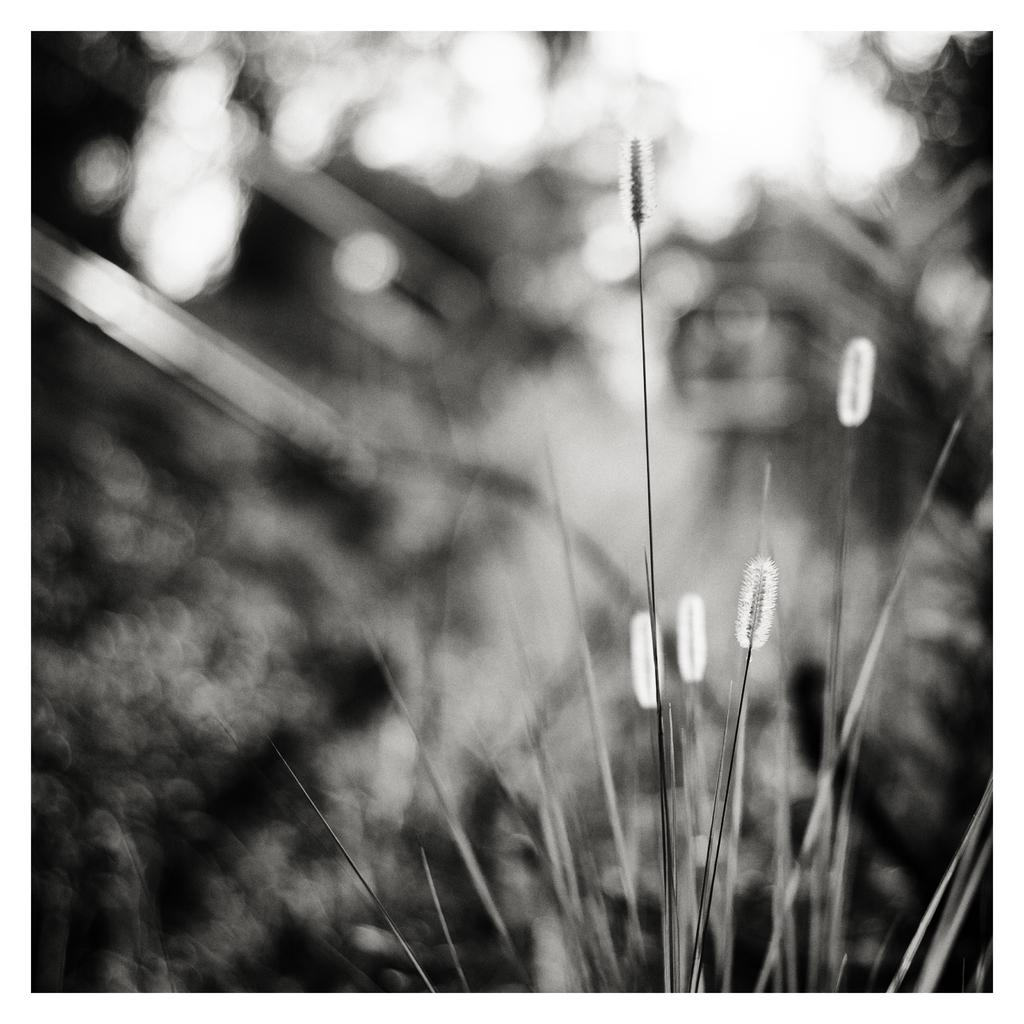What is the color scheme of the image? The image is black and white. What type of vegetation is present at the bottom of the image? There is grass at the bottom of the image. Can you describe the background of the image? The background of the image is blurry. What rule is being enforced in the image? There is no rule being enforced in the image, as it is a black and white image with grass at the bottom and a blurry background. What country is depicted in the image? The image does not depict a specific country; it is a black and white image with grass at the bottom and a blurry background. 